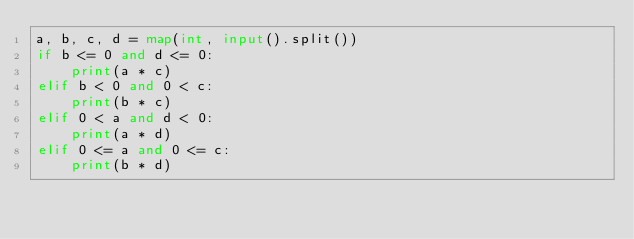Convert code to text. <code><loc_0><loc_0><loc_500><loc_500><_Python_>a, b, c, d = map(int, input().split())
if b <= 0 and d <= 0:
    print(a * c)
elif b < 0 and 0 < c:
    print(b * c)
elif 0 < a and d < 0:
    print(a * d)
elif 0 <= a and 0 <= c:
    print(b * d)</code> 